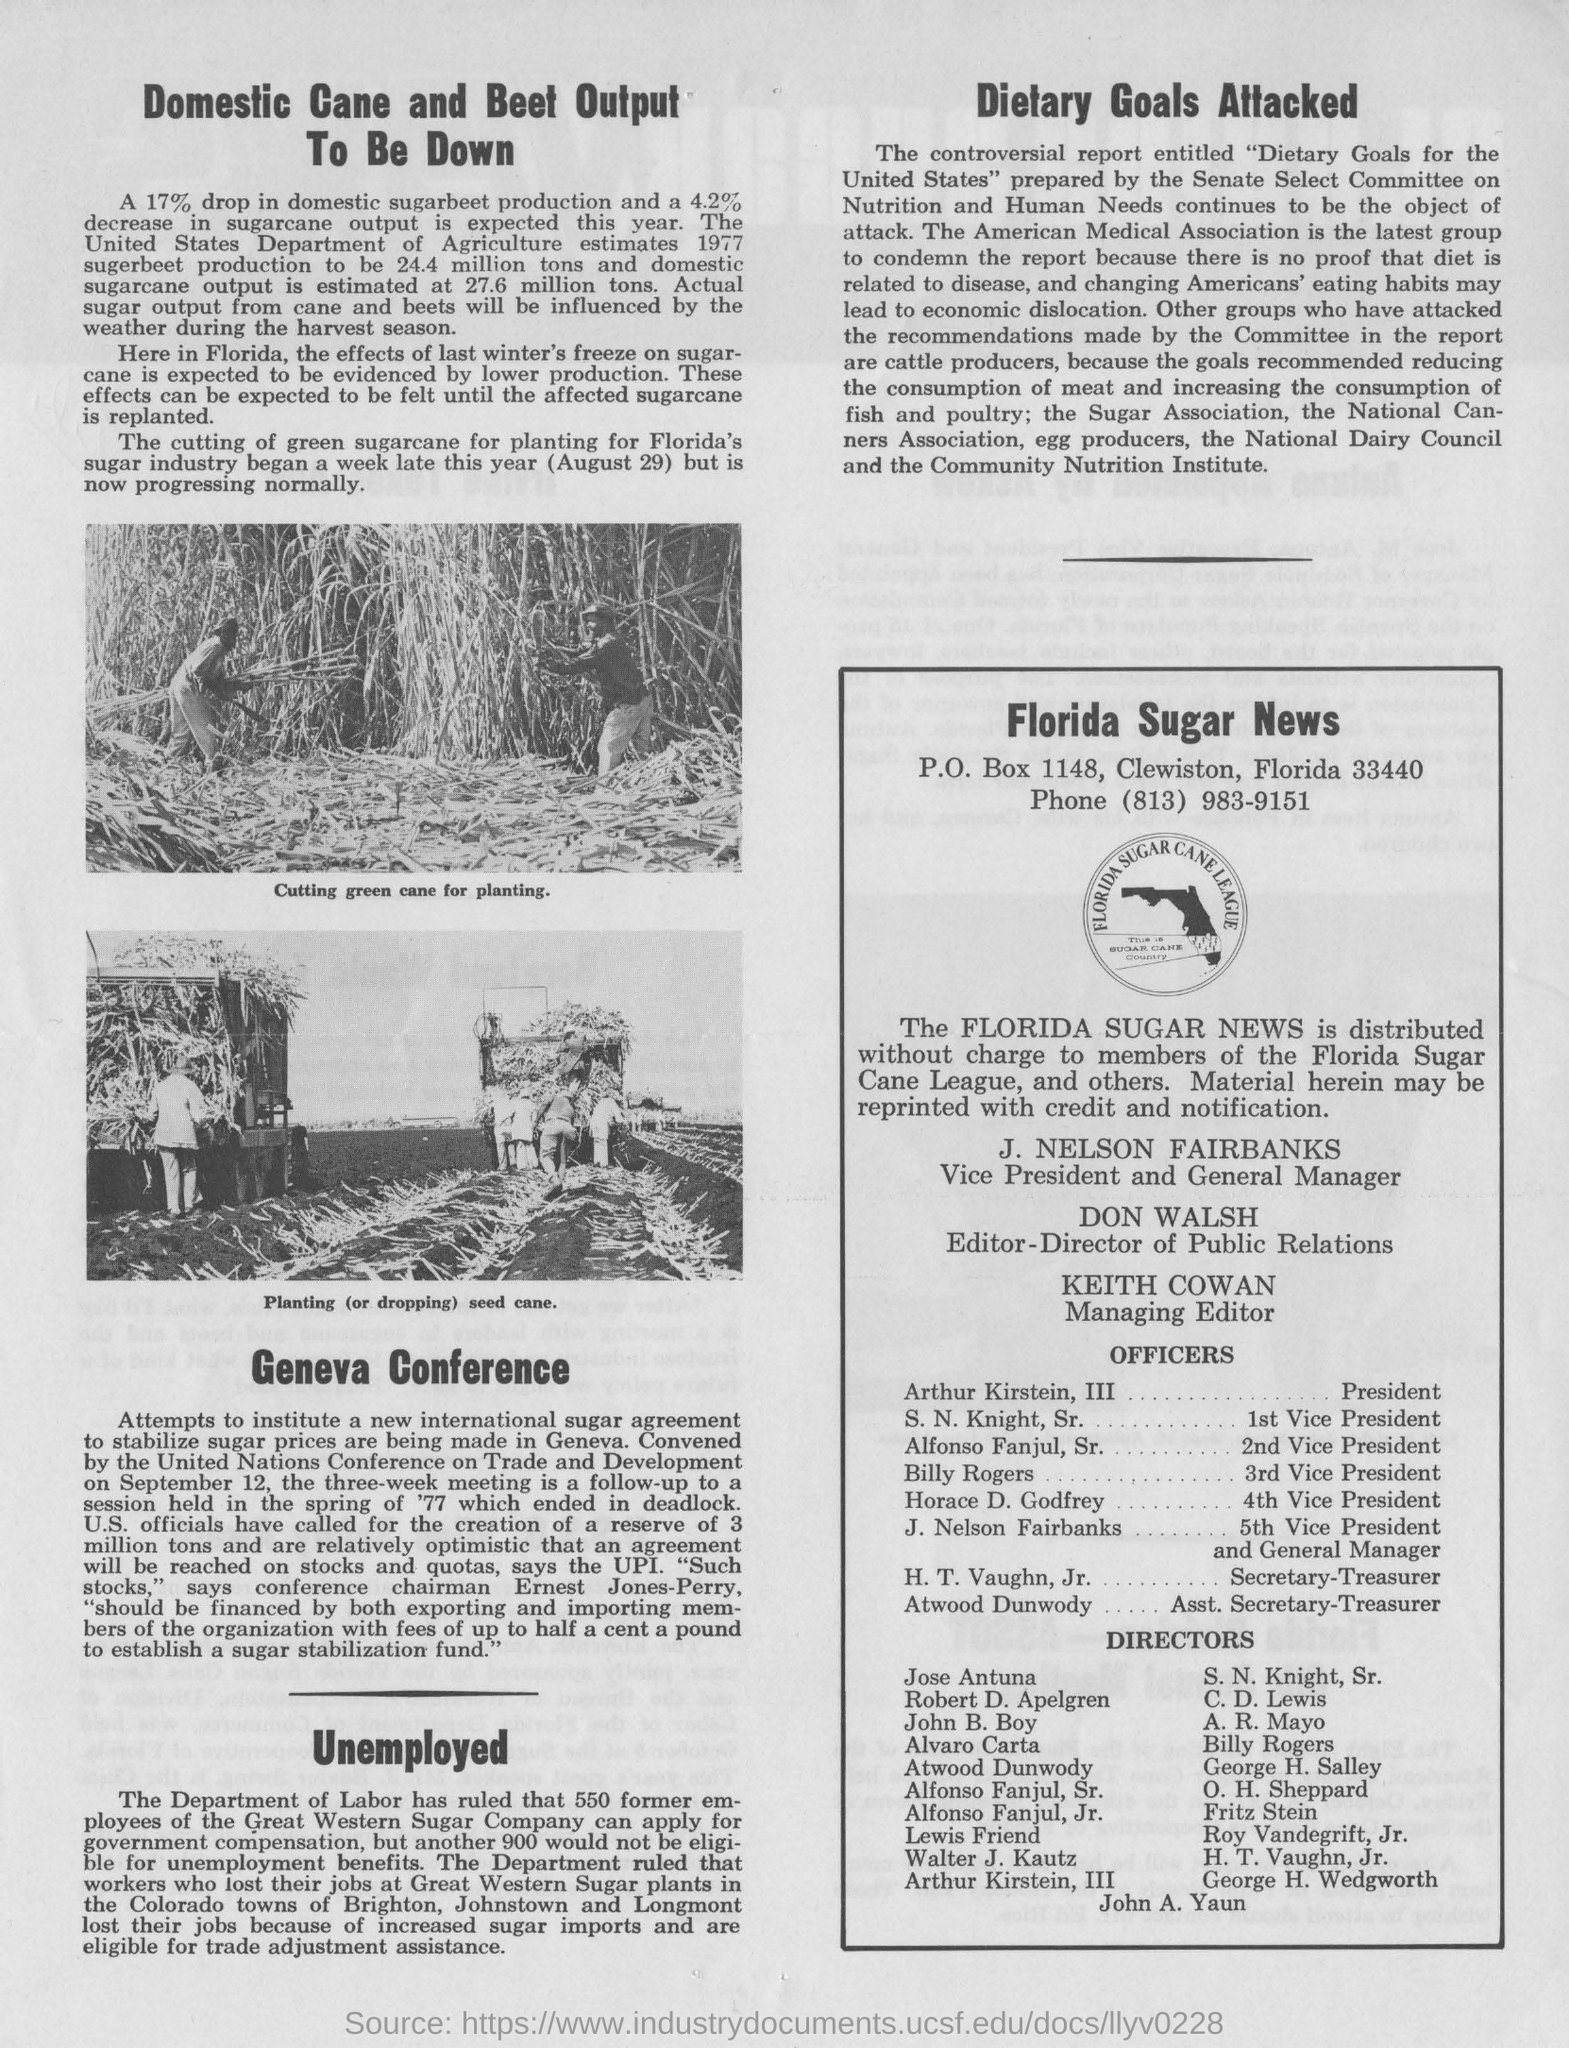Highlight a few significant elements in this photo. Keith Cowan holds the designation of Managing Editor. This year, it is expected that there will be a 17% decrease in domestic sugarbeet production. J. Nelson Fairbanks is the Vice President and General Manager of The Florida Sugar News. Sugarcane output is expected to decrease by 4.2% this year. The controversial report entitled "Dietary Goals for the United States" was prepared by the Senate Select Committee on Nutrition and Human Needs. 